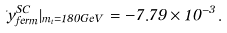Convert formula to latex. <formula><loc_0><loc_0><loc_500><loc_500>\Delta y ^ { S C } _ { f e r m } | _ { m _ { t } = 1 8 0 G e V } = - 7 . 7 9 \times 1 0 ^ { - 3 } .</formula> 